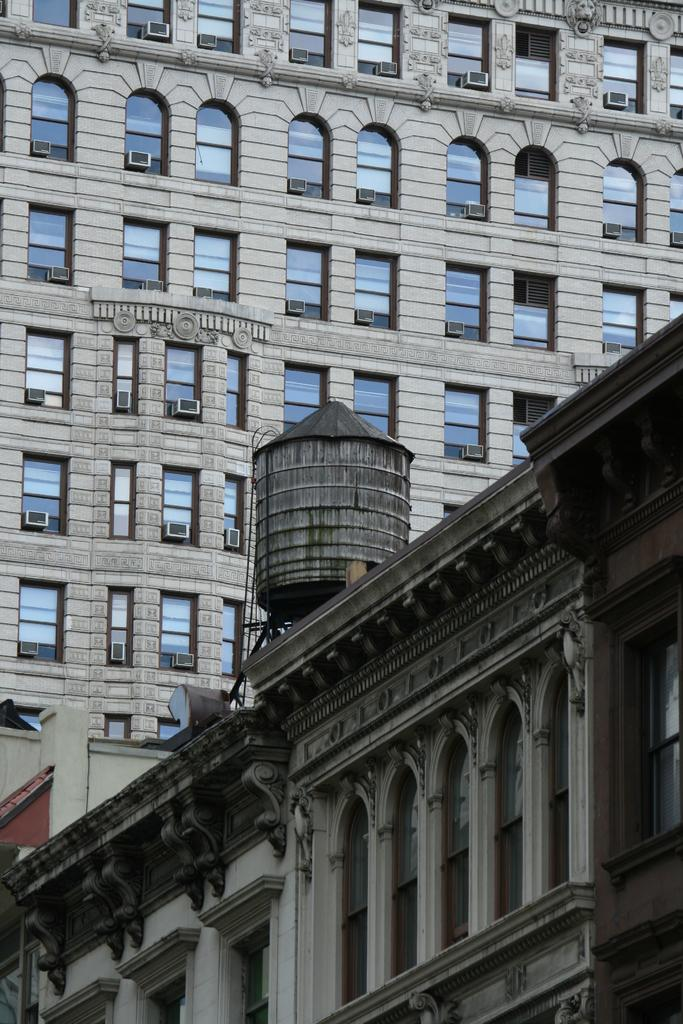What type of buildings are visible in the image? The image contains buildings, but the specific types cannot be determined without more information. What type of question is being asked in the image? There is no question present in the image, as it only contains buildings. 